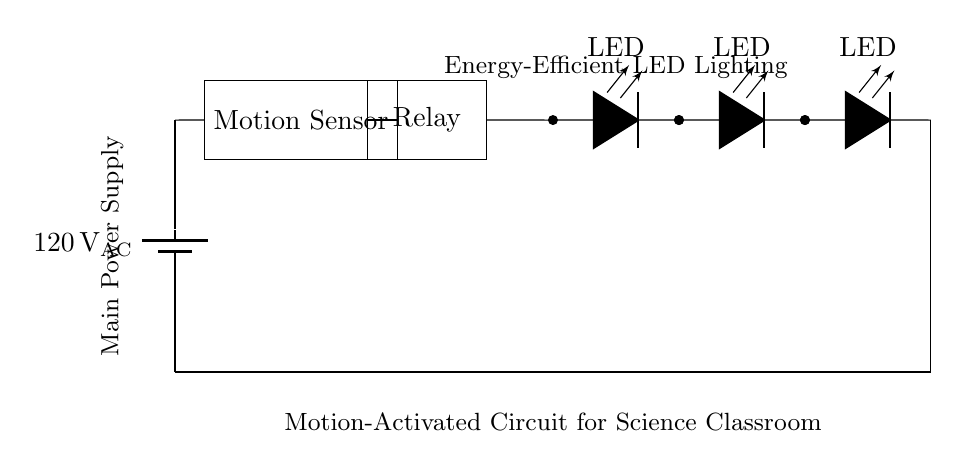What is the main power supply voltage of this circuit? The circuit is powered by a battery labeled with a voltage of 120 volts AC, which indicates the electrical potential difference provided by the main power supply.
Answer: 120 volts AC What type of sensor is used in this circuit? The circuit includes a motion sensor, which is identified in the diagram as a rectangular component labeled "Motion Sensor." This device detects movement to activate the lighting.
Answer: Motion sensor How many LED lights are in this circuit? The circuit diagram shows a series of three LED lights, each represented by the symbol for a light-emitting diode, indicating the number of lights connected in series.
Answer: Three What component controls the power to the LED lights? The relay is the component responsible for controlling the power to the LED lights. It acts as a switch that is activated by the motion sensor when movement is detected.
Answer: Relay What happens when motion is detected? When the motion sensor detects movement, it sends a signal to the relay, which closes the circuit and powers on the LED lights. This means the lighting will turn on only when there is motion in the room, enhancing energy efficiency.
Answer: LED lights turn on Which part of the circuit serves as the energy-efficient lighting? The energy-efficient lighting in this circuit is provided by the LED lights, which are commonly used for their low power consumption and long life compared to traditional lighting options.
Answer: LED lights 